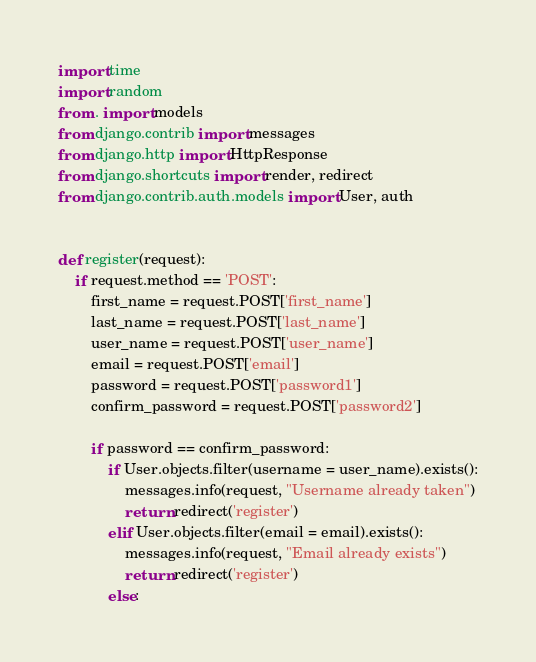<code> <loc_0><loc_0><loc_500><loc_500><_Python_>import time
import random
from . import models  
from django.contrib import messages
from django.http import HttpResponse
from django.shortcuts import render, redirect
from django.contrib.auth.models import User, auth


def register(request):
    if request.method == 'POST':
        first_name = request.POST['first_name']
        last_name = request.POST['last_name']
        user_name = request.POST['user_name']
        email = request.POST['email']
        password = request.POST['password1']
        confirm_password = request.POST['password2']

        if password == confirm_password:
            if User.objects.filter(username = user_name).exists():
                messages.info(request, "Username already taken")
                return redirect('register')
            elif User.objects.filter(email = email).exists():
                messages.info(request, "Email already exists")
                return redirect('register')
            else:</code> 